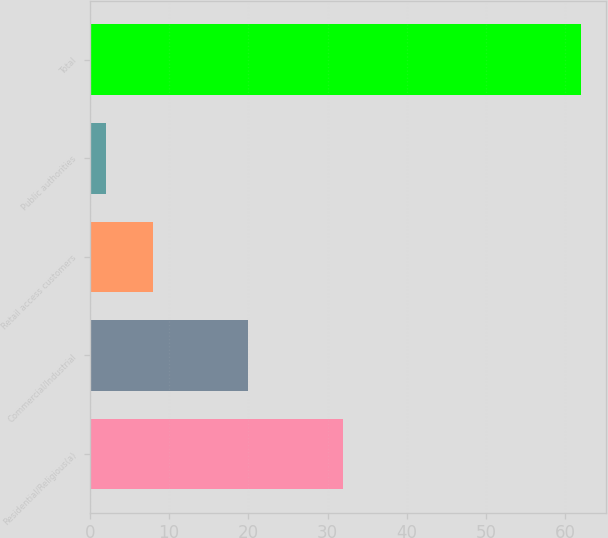Convert chart. <chart><loc_0><loc_0><loc_500><loc_500><bar_chart><fcel>Residential/Religious(a)<fcel>Commercial/Industrial<fcel>Retail access customers<fcel>Public authorities<fcel>Total<nl><fcel>32<fcel>20<fcel>8<fcel>2<fcel>62<nl></chart> 